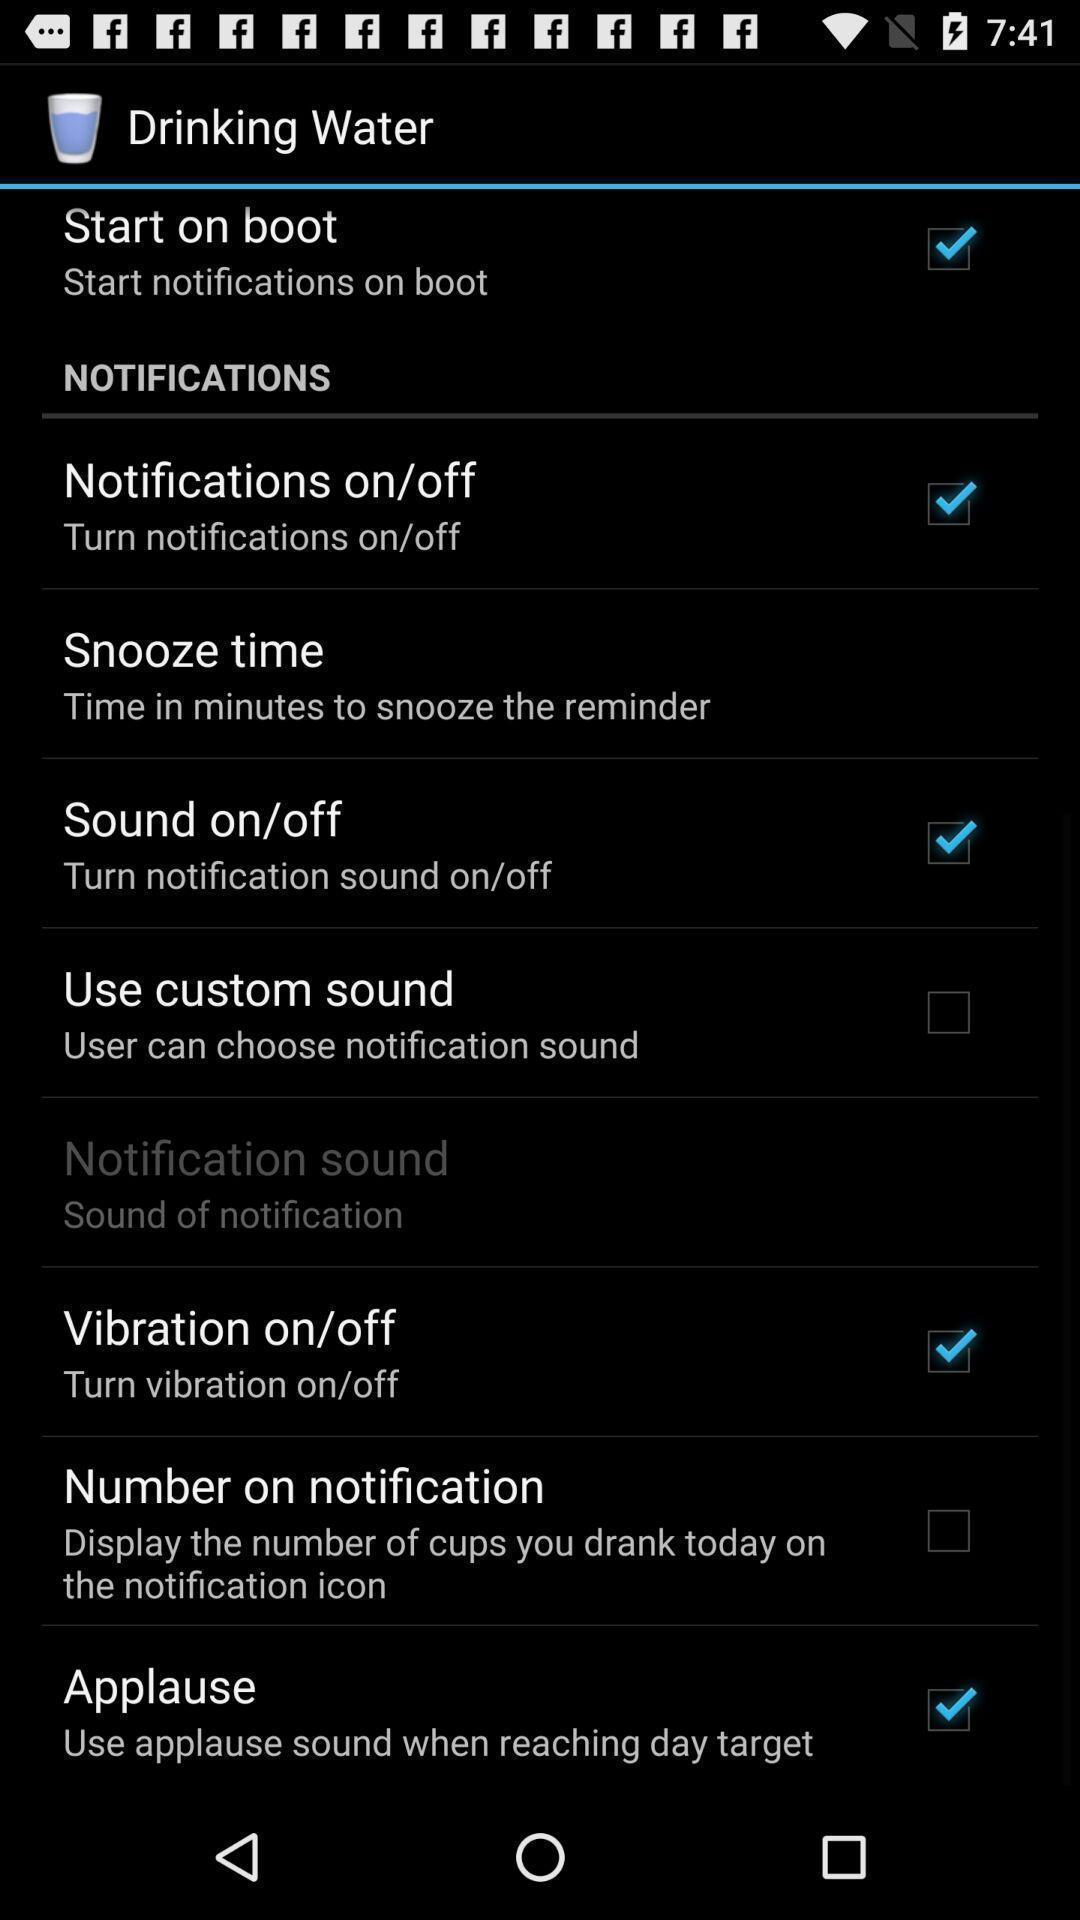Summarize the information in this screenshot. Settings page of water drinking reminder app. 